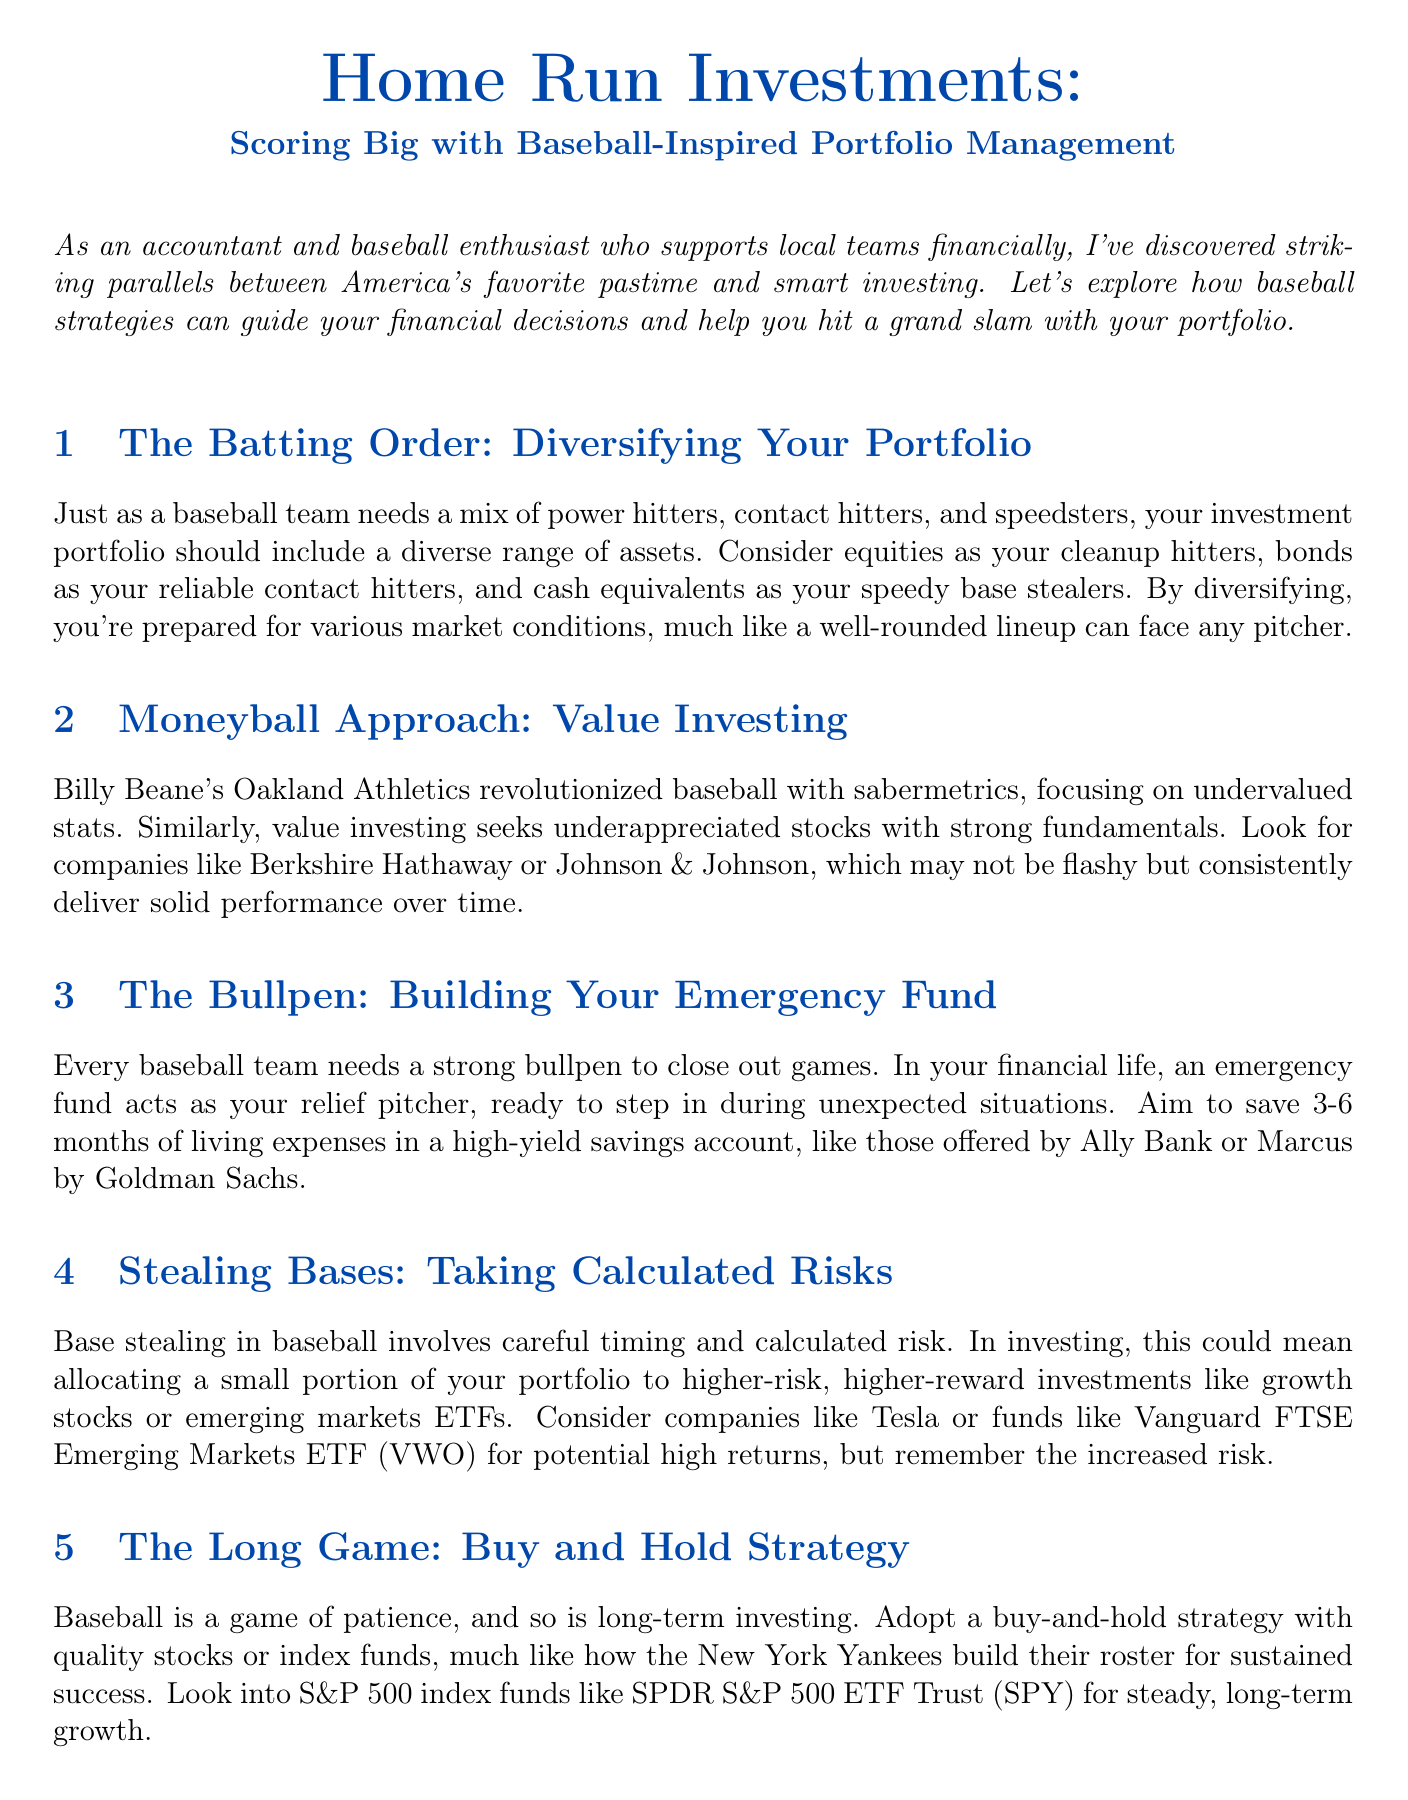What is the title of the newsletter? The title of the newsletter is the main heading displayed prominently at the top of the document.
Answer: Home Run Investments: Scoring Big with Baseball-Inspired Portfolio Management What is the main analogy used for emergency funds? The analogy compares emergency funds to a specific part of a baseball team that provides essential support during critical moments.
Answer: Relief pitcher What percentage increase did the Oakville Oakers achieve in revenue? This information pertains to a specific financial success detailed in the case study regarding the Oakville Oakers.
Answer: 30% Which companies are mentioned as examples of value investing? These examples are cited in relation to the strategy of seeking undervalued stocks with strong fundamentals.
Answer: Berkshire Hathaway, Johnson & Johnson How many months of living expenses should you aim to save for your emergency fund? This question seeks a specific recommendation mentioned in the content regarding the ideal amount for an emergency fund.
Answer: 3-6 months What is the recommended investment strategy for long-term growth? This strategy is noted in the document as a method for achieving sustained success in investing over time.
Answer: Buy-and-hold strategy What financial action is compared to adjusting a baseball lineup? This phrase from the document connects a financial practice with a common action in baseball gameplay.
Answer: Regular rebalancing What should you monitor regularly according to the tips section? The context indicates this is an essential aspect of keeping track of your investments effectively.
Answer: Investments 